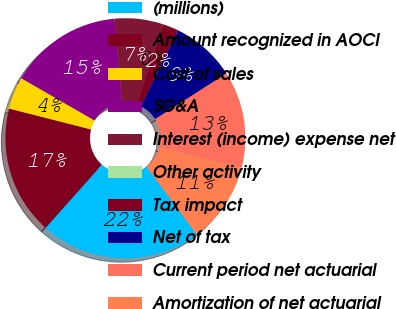<chart> <loc_0><loc_0><loc_500><loc_500><pie_chart><fcel>(millions)<fcel>Amount recognized in AOCI<fcel>Cost of sales<fcel>SG&A<fcel>Interest (income) expense net<fcel>Other activity<fcel>Tax impact<fcel>Net of tax<fcel>Current period net actuarial<fcel>Amortization of net actuarial<nl><fcel>21.74%<fcel>17.39%<fcel>4.35%<fcel>15.22%<fcel>6.52%<fcel>0.0%<fcel>2.18%<fcel>8.7%<fcel>13.04%<fcel>10.87%<nl></chart> 